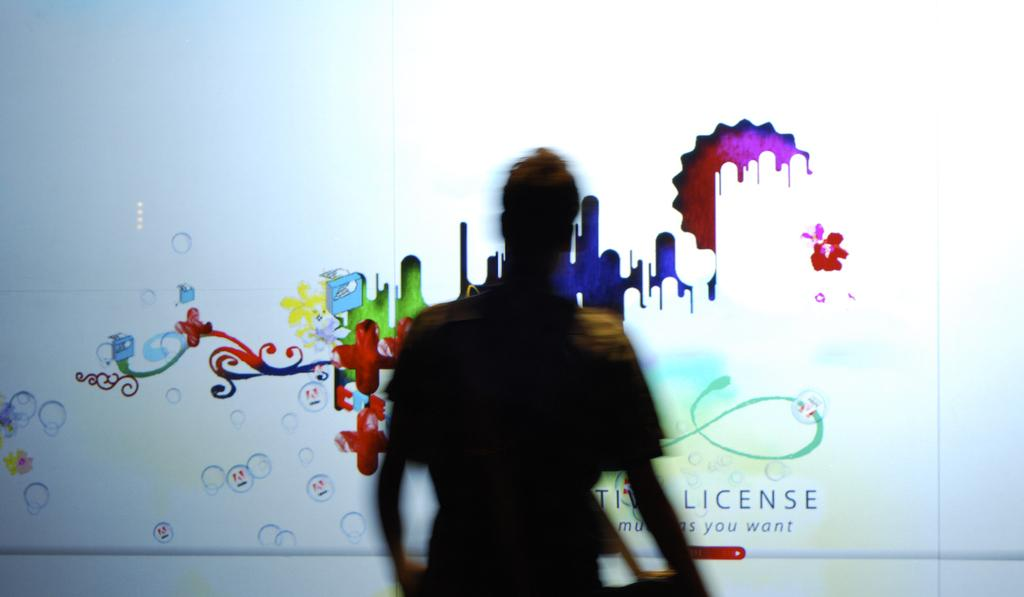What is the main subject of the image? There is a person standing in the image. What can be seen in the person's hand? There is a glass in the person's hand. Can you describe the design on the glass? Yes, there is a design on the glass in the image. Is there any text on the glass? Yes, there is writing on the glass in the image. What type of iron can be seen in the image? There is no iron present in the image. Can you describe the owl sitting on the glass in the image? There is no owl present in the image. 